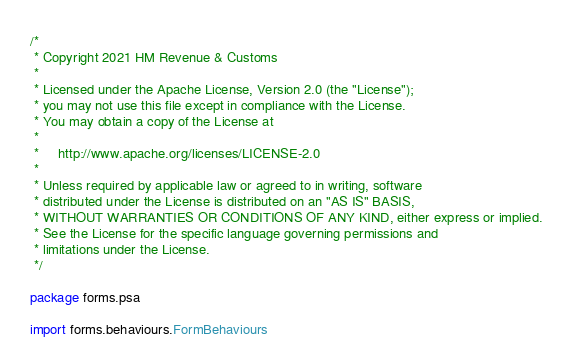Convert code to text. <code><loc_0><loc_0><loc_500><loc_500><_Scala_>/*
 * Copyright 2021 HM Revenue & Customs
 *
 * Licensed under the Apache License, Version 2.0 (the "License");
 * you may not use this file except in compliance with the License.
 * You may obtain a copy of the License at
 *
 *     http://www.apache.org/licenses/LICENSE-2.0
 *
 * Unless required by applicable law or agreed to in writing, software
 * distributed under the License is distributed on an "AS IS" BASIS,
 * WITHOUT WARRANTIES OR CONDITIONS OF ANY KIND, either express or implied.
 * See the License for the specific language governing permissions and
 * limitations under the License.
 */

package forms.psa

import forms.behaviours.FormBehaviours</code> 